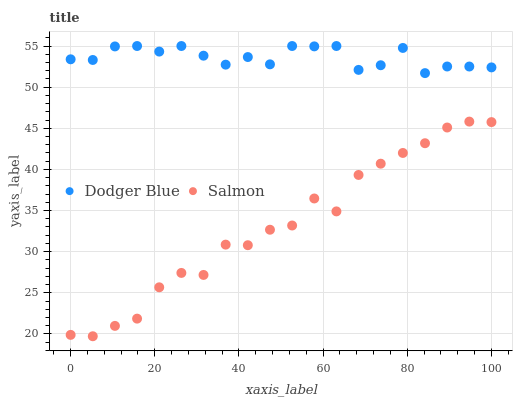Does Salmon have the minimum area under the curve?
Answer yes or no. Yes. Does Dodger Blue have the maximum area under the curve?
Answer yes or no. Yes. Does Dodger Blue have the minimum area under the curve?
Answer yes or no. No. Is Dodger Blue the smoothest?
Answer yes or no. Yes. Is Salmon the roughest?
Answer yes or no. Yes. Is Dodger Blue the roughest?
Answer yes or no. No. Does Salmon have the lowest value?
Answer yes or no. Yes. Does Dodger Blue have the lowest value?
Answer yes or no. No. Does Dodger Blue have the highest value?
Answer yes or no. Yes. Is Salmon less than Dodger Blue?
Answer yes or no. Yes. Is Dodger Blue greater than Salmon?
Answer yes or no. Yes. Does Salmon intersect Dodger Blue?
Answer yes or no. No. 